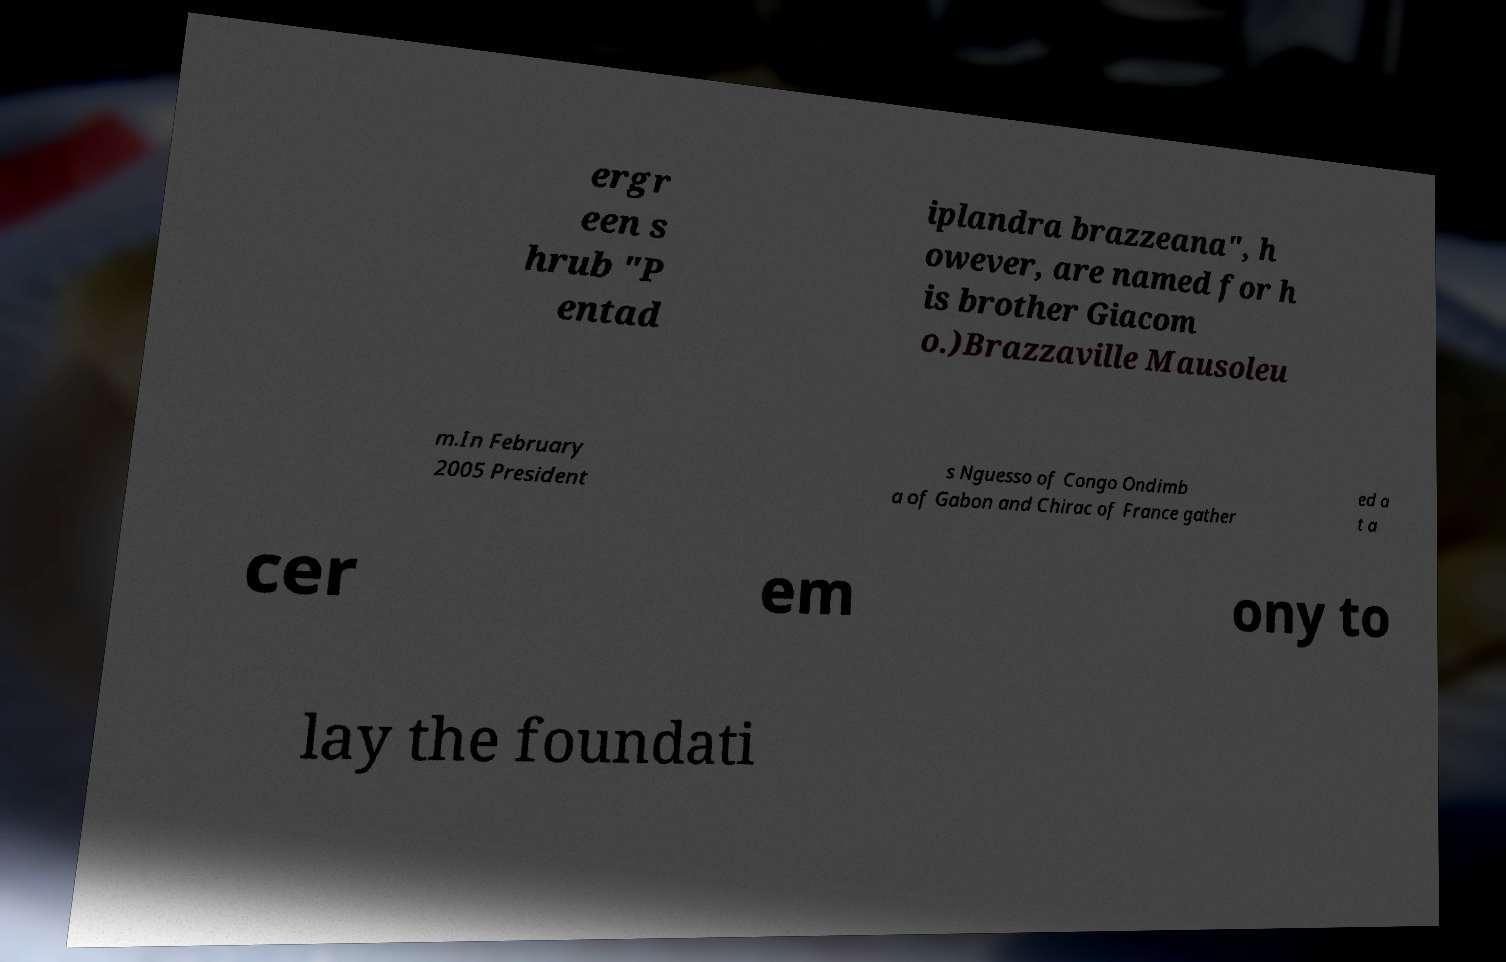Can you read and provide the text displayed in the image?This photo seems to have some interesting text. Can you extract and type it out for me? ergr een s hrub "P entad iplandra brazzeana", h owever, are named for h is brother Giacom o.)Brazzaville Mausoleu m.In February 2005 President s Nguesso of Congo Ondimb a of Gabon and Chirac of France gather ed a t a cer em ony to lay the foundati 